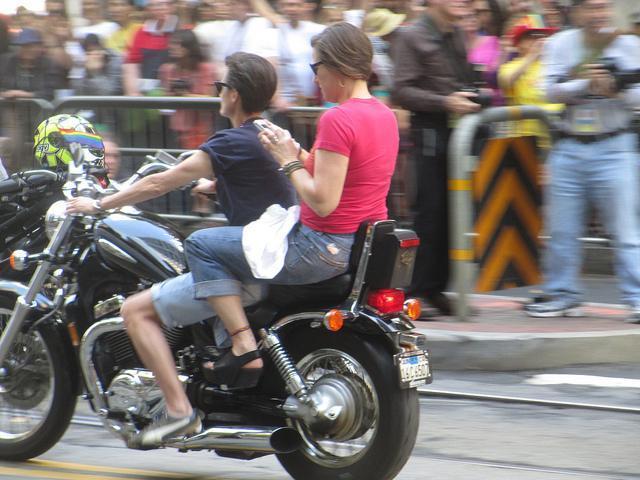How many people are on the motorcycle?
Give a very brief answer. 2. How many people are visible?
Give a very brief answer. 11. How many chairs are facing the far wall?
Give a very brief answer. 0. 